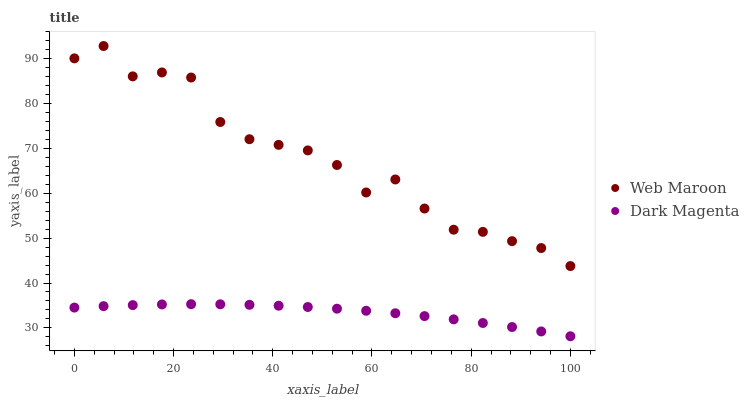Does Dark Magenta have the minimum area under the curve?
Answer yes or no. Yes. Does Web Maroon have the maximum area under the curve?
Answer yes or no. Yes. Does Dark Magenta have the maximum area under the curve?
Answer yes or no. No. Is Dark Magenta the smoothest?
Answer yes or no. Yes. Is Web Maroon the roughest?
Answer yes or no. Yes. Is Dark Magenta the roughest?
Answer yes or no. No. Does Dark Magenta have the lowest value?
Answer yes or no. Yes. Does Web Maroon have the highest value?
Answer yes or no. Yes. Does Dark Magenta have the highest value?
Answer yes or no. No. Is Dark Magenta less than Web Maroon?
Answer yes or no. Yes. Is Web Maroon greater than Dark Magenta?
Answer yes or no. Yes. Does Dark Magenta intersect Web Maroon?
Answer yes or no. No. 